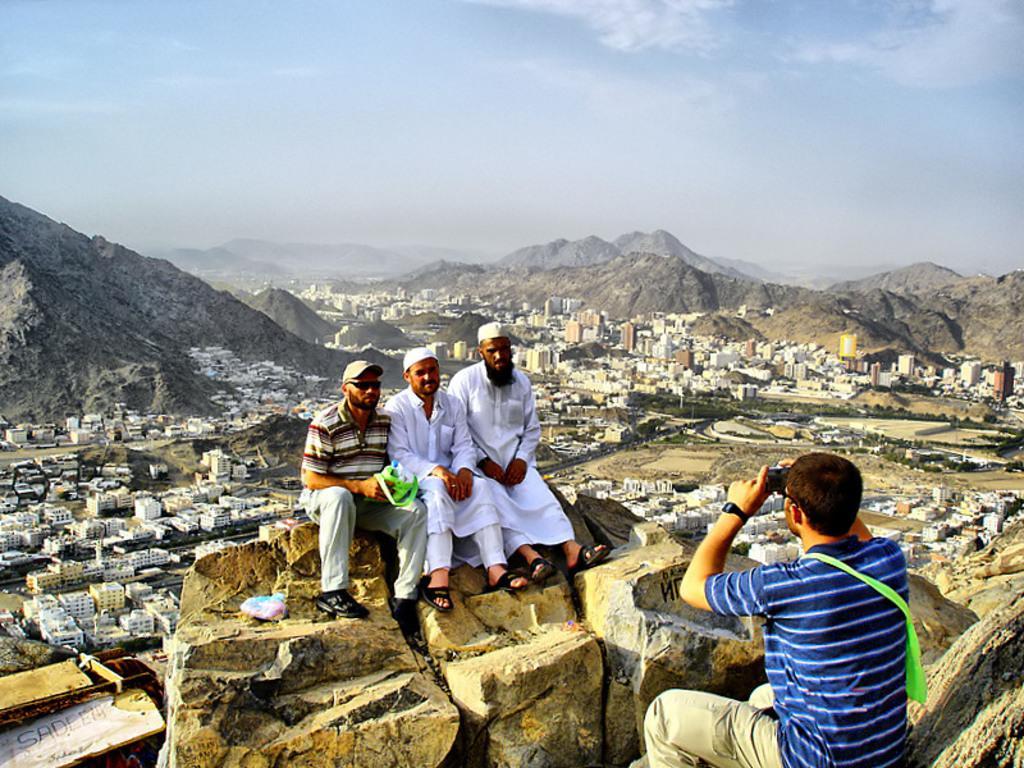How would you summarize this image in a sentence or two? In the image we can see there are people sitting on the rock and there is a man sitting and holding camera in his hand. Behind there are buildings and there are hills. 